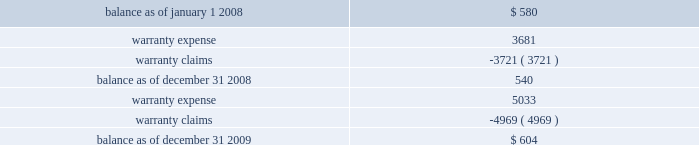Investments prior to our acquisition of keystone on october 12 , 2007 , we held common shares of keystone , which were classified as an available-for-sale investment security .
Accordingly , the investment was included in other assets at its fair value , with the unrealized gain excluded from earnings and included in accumulated other comprehensive income , net of applicable taxes .
Upon our acquisition of keystone on october 12 , 2007 , the unrealized gain was removed from accumulated other comprehensive income , net of applicable taxes , and the original cost of the common shares was considered a component of the purchase price .
Fair value of financial instruments our debt is reflected on the balance sheet at cost .
Based on current market conditions , our interest rate margins are below the rate available in the market , which causes the fair value of our debt to fall below the carrying value .
The fair value of our term loans ( see note 6 , 201clong-term obligations 201d ) is approximately $ 570 million at december 31 , 2009 , as compared to the carrying value of $ 596 million .
We estimated the fair value of our term loans by calculating the upfront cash payment a market participant would require to assume our obligations .
The upfront cash payment , excluding any issuance costs , is the amount that a market participant would be able to lend at december 31 , 2009 to an entity with a credit rating similar to ours and achieve sufficient cash inflows to cover the scheduled cash outflows under our term loans .
The carrying amounts of our cash and equivalents , net trade receivables and accounts payable approximate fair value .
We apply the market approach to value our financial assets and liabilities , which include the cash surrender value of life insurance , deferred compensation liabilities and interest rate swaps .
The market approach utilizes available market information to estimate fair value .
Required fair value disclosures are included in note 8 , 201cfair value measurements . 201d accrued expenses we self-insure a portion of employee medical benefits under the terms of our employee health insurance program .
We purchase certain stop-loss insurance to limit our liability exposure .
We also self-insure a portion of our property and casualty risk , which includes automobile liability , general liability , workers 2019 compensation and property under deductible insurance programs .
The insurance premium costs are expensed over the contract periods .
A reserve for liabilities associated with these losses is established for claims filed and claims incurred but not yet reported based upon our estimate of ultimate cost , which is calculated using analyses of historical data .
We monitor new claims and claim development as well as trends related to the claims incurred but not reported in order to assess the adequacy of our insurance reserves .
Self-insurance reserves on the consolidated balance sheets are net of claims deposits of $ 0.7 million and $ 0.8 million , at december 31 , 2009 and 2008 , respectively .
While we do not expect the amounts ultimately paid to differ significantly from our estimates , our insurance reserves and corresponding expenses could be affected if future claim experience differs significantly from historical trends and assumptions .
Product warranties some of our mechanical products are sold with a standard six-month warranty against defects .
We record the estimated warranty costs at the time of sale using historical warranty claim information to project future warranty claims activity and related expenses .
The changes in the warranty reserve are as follows ( in thousands ) : .

What was the percentage change in warranty reserves from 2008 to 2009? 
Computations: ((604 - 540) / 540)
Answer: 0.11852. Investments prior to our acquisition of keystone on october 12 , 2007 , we held common shares of keystone , which were classified as an available-for-sale investment security .
Accordingly , the investment was included in other assets at its fair value , with the unrealized gain excluded from earnings and included in accumulated other comprehensive income , net of applicable taxes .
Upon our acquisition of keystone on october 12 , 2007 , the unrealized gain was removed from accumulated other comprehensive income , net of applicable taxes , and the original cost of the common shares was considered a component of the purchase price .
Fair value of financial instruments our debt is reflected on the balance sheet at cost .
Based on current market conditions , our interest rate margins are below the rate available in the market , which causes the fair value of our debt to fall below the carrying value .
The fair value of our term loans ( see note 6 , 201clong-term obligations 201d ) is approximately $ 570 million at december 31 , 2009 , as compared to the carrying value of $ 596 million .
We estimated the fair value of our term loans by calculating the upfront cash payment a market participant would require to assume our obligations .
The upfront cash payment , excluding any issuance costs , is the amount that a market participant would be able to lend at december 31 , 2009 to an entity with a credit rating similar to ours and achieve sufficient cash inflows to cover the scheduled cash outflows under our term loans .
The carrying amounts of our cash and equivalents , net trade receivables and accounts payable approximate fair value .
We apply the market approach to value our financial assets and liabilities , which include the cash surrender value of life insurance , deferred compensation liabilities and interest rate swaps .
The market approach utilizes available market information to estimate fair value .
Required fair value disclosures are included in note 8 , 201cfair value measurements . 201d accrued expenses we self-insure a portion of employee medical benefits under the terms of our employee health insurance program .
We purchase certain stop-loss insurance to limit our liability exposure .
We also self-insure a portion of our property and casualty risk , which includes automobile liability , general liability , workers 2019 compensation and property under deductible insurance programs .
The insurance premium costs are expensed over the contract periods .
A reserve for liabilities associated with these losses is established for claims filed and claims incurred but not yet reported based upon our estimate of ultimate cost , which is calculated using analyses of historical data .
We monitor new claims and claim development as well as trends related to the claims incurred but not reported in order to assess the adequacy of our insurance reserves .
Self-insurance reserves on the consolidated balance sheets are net of claims deposits of $ 0.7 million and $ 0.8 million , at december 31 , 2009 and 2008 , respectively .
While we do not expect the amounts ultimately paid to differ significantly from our estimates , our insurance reserves and corresponding expenses could be affected if future claim experience differs significantly from historical trends and assumptions .
Product warranties some of our mechanical products are sold with a standard six-month warranty against defects .
We record the estimated warranty costs at the time of sale using historical warranty claim information to project future warranty claims activity and related expenses .
The changes in the warranty reserve are as follows ( in thousands ) : .

At december 2009 what was the range between the carrying and the fair value of our term loans? 
Computations: (570 - 596)
Answer: -26.0. 